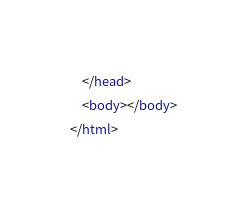<code> <loc_0><loc_0><loc_500><loc_500><_HTML_>	</head>
	<body></body>
</html>
</code> 